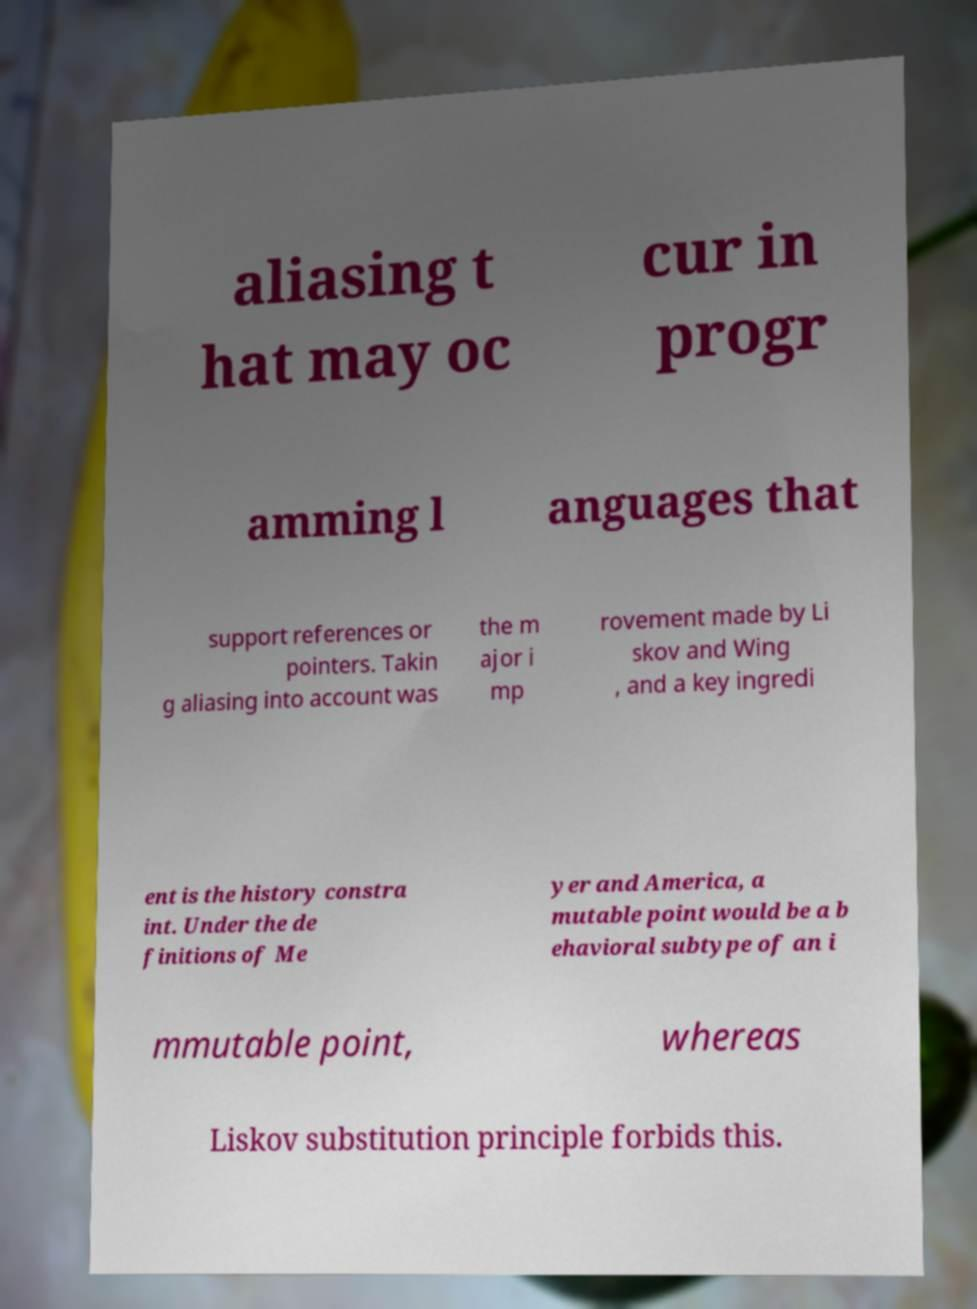For documentation purposes, I need the text within this image transcribed. Could you provide that? aliasing t hat may oc cur in progr amming l anguages that support references or pointers. Takin g aliasing into account was the m ajor i mp rovement made by Li skov and Wing , and a key ingredi ent is the history constra int. Under the de finitions of Me yer and America, a mutable point would be a b ehavioral subtype of an i mmutable point, whereas Liskov substitution principle forbids this. 